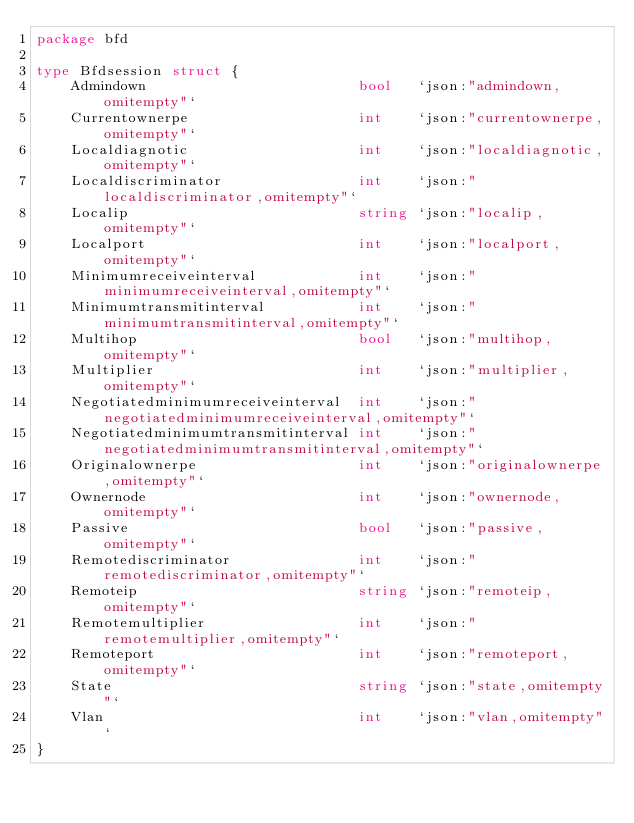<code> <loc_0><loc_0><loc_500><loc_500><_Go_>package bfd

type Bfdsession struct {
	Admindown                         bool   `json:"admindown,omitempty"`
	Currentownerpe                    int    `json:"currentownerpe,omitempty"`
	Localdiagnotic                    int    `json:"localdiagnotic,omitempty"`
	Localdiscriminator                int    `json:"localdiscriminator,omitempty"`
	Localip                           string `json:"localip,omitempty"`
	Localport                         int    `json:"localport,omitempty"`
	Minimumreceiveinterval            int    `json:"minimumreceiveinterval,omitempty"`
	Minimumtransmitinterval           int    `json:"minimumtransmitinterval,omitempty"`
	Multihop                          bool   `json:"multihop,omitempty"`
	Multiplier                        int    `json:"multiplier,omitempty"`
	Negotiatedminimumreceiveinterval  int    `json:"negotiatedminimumreceiveinterval,omitempty"`
	Negotiatedminimumtransmitinterval int    `json:"negotiatedminimumtransmitinterval,omitempty"`
	Originalownerpe                   int    `json:"originalownerpe,omitempty"`
	Ownernode                         int    `json:"ownernode,omitempty"`
	Passive                           bool   `json:"passive,omitempty"`
	Remotediscriminator               int    `json:"remotediscriminator,omitempty"`
	Remoteip                          string `json:"remoteip,omitempty"`
	Remotemultiplier                  int    `json:"remotemultiplier,omitempty"`
	Remoteport                        int    `json:"remoteport,omitempty"`
	State                             string `json:"state,omitempty"`
	Vlan                              int    `json:"vlan,omitempty"`
}
</code> 